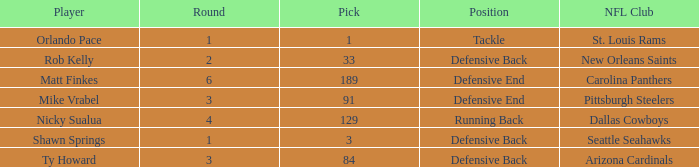What player has defensive back as the position, with a round less than 2? Shawn Springs. 